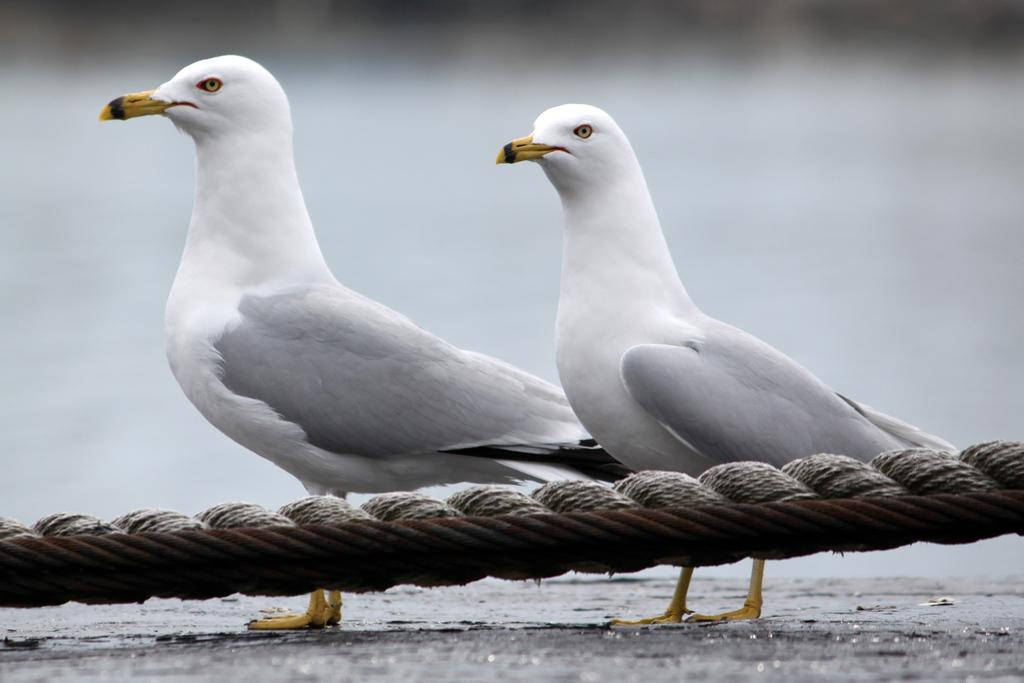What type of animals can be seen in the image? There are birds in the image. What objects are present in the image besides the birds? There are ropes in the image. Can you describe the background of the image? The background of the image is blurred. What page of the book is the parcel mentioned on? There is no book or parcel present in the image, so it's not possible to determine which page the parcel might be mentioned on. 